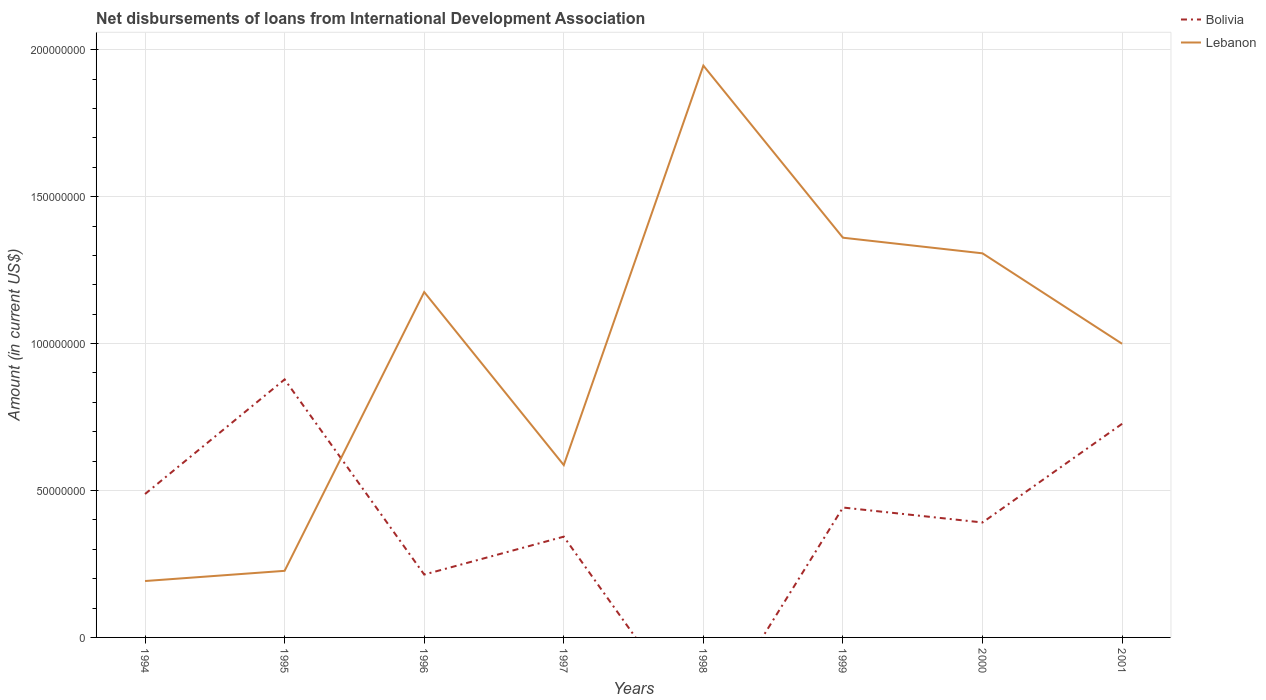How many different coloured lines are there?
Keep it short and to the point. 2. Is the number of lines equal to the number of legend labels?
Give a very brief answer. No. Across all years, what is the maximum amount of loans disbursed in Lebanon?
Offer a very short reply. 1.92e+07. What is the total amount of loans disbursed in Lebanon in the graph?
Make the answer very short. -3.95e+07. What is the difference between the highest and the second highest amount of loans disbursed in Lebanon?
Offer a terse response. 1.75e+08. What is the difference between the highest and the lowest amount of loans disbursed in Bolivia?
Your answer should be compact. 4. How many lines are there?
Your response must be concise. 2. Are the values on the major ticks of Y-axis written in scientific E-notation?
Your response must be concise. No. Does the graph contain grids?
Offer a terse response. Yes. How many legend labels are there?
Offer a terse response. 2. What is the title of the graph?
Your answer should be compact. Net disbursements of loans from International Development Association. What is the label or title of the X-axis?
Provide a succinct answer. Years. What is the Amount (in current US$) in Bolivia in 1994?
Ensure brevity in your answer.  4.88e+07. What is the Amount (in current US$) in Lebanon in 1994?
Ensure brevity in your answer.  1.92e+07. What is the Amount (in current US$) in Bolivia in 1995?
Make the answer very short. 8.78e+07. What is the Amount (in current US$) of Lebanon in 1995?
Ensure brevity in your answer.  2.27e+07. What is the Amount (in current US$) of Bolivia in 1996?
Your response must be concise. 2.14e+07. What is the Amount (in current US$) in Lebanon in 1996?
Offer a terse response. 1.18e+08. What is the Amount (in current US$) in Bolivia in 1997?
Make the answer very short. 3.43e+07. What is the Amount (in current US$) of Lebanon in 1997?
Make the answer very short. 5.87e+07. What is the Amount (in current US$) of Lebanon in 1998?
Your answer should be compact. 1.95e+08. What is the Amount (in current US$) in Bolivia in 1999?
Your response must be concise. 4.42e+07. What is the Amount (in current US$) of Lebanon in 1999?
Offer a terse response. 1.36e+08. What is the Amount (in current US$) in Bolivia in 2000?
Ensure brevity in your answer.  3.91e+07. What is the Amount (in current US$) in Lebanon in 2000?
Provide a short and direct response. 1.31e+08. What is the Amount (in current US$) of Bolivia in 2001?
Your answer should be very brief. 7.27e+07. What is the Amount (in current US$) of Lebanon in 2001?
Provide a short and direct response. 9.99e+07. Across all years, what is the maximum Amount (in current US$) of Bolivia?
Your answer should be compact. 8.78e+07. Across all years, what is the maximum Amount (in current US$) in Lebanon?
Provide a short and direct response. 1.95e+08. Across all years, what is the minimum Amount (in current US$) of Lebanon?
Make the answer very short. 1.92e+07. What is the total Amount (in current US$) in Bolivia in the graph?
Make the answer very short. 3.48e+08. What is the total Amount (in current US$) in Lebanon in the graph?
Give a very brief answer. 7.79e+08. What is the difference between the Amount (in current US$) of Bolivia in 1994 and that in 1995?
Make the answer very short. -3.90e+07. What is the difference between the Amount (in current US$) of Lebanon in 1994 and that in 1995?
Your answer should be compact. -3.47e+06. What is the difference between the Amount (in current US$) in Bolivia in 1994 and that in 1996?
Offer a terse response. 2.74e+07. What is the difference between the Amount (in current US$) in Lebanon in 1994 and that in 1996?
Offer a terse response. -9.84e+07. What is the difference between the Amount (in current US$) in Bolivia in 1994 and that in 1997?
Give a very brief answer. 1.45e+07. What is the difference between the Amount (in current US$) of Lebanon in 1994 and that in 1997?
Your answer should be compact. -3.95e+07. What is the difference between the Amount (in current US$) of Lebanon in 1994 and that in 1998?
Your answer should be compact. -1.75e+08. What is the difference between the Amount (in current US$) in Bolivia in 1994 and that in 1999?
Make the answer very short. 4.60e+06. What is the difference between the Amount (in current US$) in Lebanon in 1994 and that in 1999?
Your response must be concise. -1.17e+08. What is the difference between the Amount (in current US$) of Bolivia in 1994 and that in 2000?
Your response must be concise. 9.69e+06. What is the difference between the Amount (in current US$) of Lebanon in 1994 and that in 2000?
Your response must be concise. -1.12e+08. What is the difference between the Amount (in current US$) of Bolivia in 1994 and that in 2001?
Give a very brief answer. -2.39e+07. What is the difference between the Amount (in current US$) of Lebanon in 1994 and that in 2001?
Your response must be concise. -8.07e+07. What is the difference between the Amount (in current US$) in Bolivia in 1995 and that in 1996?
Your answer should be compact. 6.64e+07. What is the difference between the Amount (in current US$) of Lebanon in 1995 and that in 1996?
Your answer should be compact. -9.49e+07. What is the difference between the Amount (in current US$) of Bolivia in 1995 and that in 1997?
Make the answer very short. 5.35e+07. What is the difference between the Amount (in current US$) of Lebanon in 1995 and that in 1997?
Make the answer very short. -3.60e+07. What is the difference between the Amount (in current US$) in Lebanon in 1995 and that in 1998?
Your answer should be very brief. -1.72e+08. What is the difference between the Amount (in current US$) in Bolivia in 1995 and that in 1999?
Offer a very short reply. 4.36e+07. What is the difference between the Amount (in current US$) in Lebanon in 1995 and that in 1999?
Give a very brief answer. -1.13e+08. What is the difference between the Amount (in current US$) in Bolivia in 1995 and that in 2000?
Make the answer very short. 4.87e+07. What is the difference between the Amount (in current US$) in Lebanon in 1995 and that in 2000?
Your answer should be compact. -1.08e+08. What is the difference between the Amount (in current US$) in Bolivia in 1995 and that in 2001?
Offer a terse response. 1.51e+07. What is the difference between the Amount (in current US$) in Lebanon in 1995 and that in 2001?
Provide a succinct answer. -7.73e+07. What is the difference between the Amount (in current US$) of Bolivia in 1996 and that in 1997?
Your answer should be compact. -1.29e+07. What is the difference between the Amount (in current US$) of Lebanon in 1996 and that in 1997?
Your response must be concise. 5.89e+07. What is the difference between the Amount (in current US$) in Lebanon in 1996 and that in 1998?
Offer a terse response. -7.71e+07. What is the difference between the Amount (in current US$) of Bolivia in 1996 and that in 1999?
Ensure brevity in your answer.  -2.28e+07. What is the difference between the Amount (in current US$) of Lebanon in 1996 and that in 1999?
Ensure brevity in your answer.  -1.85e+07. What is the difference between the Amount (in current US$) in Bolivia in 1996 and that in 2000?
Offer a very short reply. -1.77e+07. What is the difference between the Amount (in current US$) in Lebanon in 1996 and that in 2000?
Your answer should be very brief. -1.32e+07. What is the difference between the Amount (in current US$) of Bolivia in 1996 and that in 2001?
Your answer should be very brief. -5.13e+07. What is the difference between the Amount (in current US$) of Lebanon in 1996 and that in 2001?
Provide a succinct answer. 1.76e+07. What is the difference between the Amount (in current US$) in Lebanon in 1997 and that in 1998?
Give a very brief answer. -1.36e+08. What is the difference between the Amount (in current US$) in Bolivia in 1997 and that in 1999?
Provide a succinct answer. -9.91e+06. What is the difference between the Amount (in current US$) of Lebanon in 1997 and that in 1999?
Your response must be concise. -7.74e+07. What is the difference between the Amount (in current US$) in Bolivia in 1997 and that in 2000?
Offer a very short reply. -4.82e+06. What is the difference between the Amount (in current US$) in Lebanon in 1997 and that in 2000?
Offer a terse response. -7.21e+07. What is the difference between the Amount (in current US$) in Bolivia in 1997 and that in 2001?
Make the answer very short. -3.84e+07. What is the difference between the Amount (in current US$) of Lebanon in 1997 and that in 2001?
Offer a very short reply. -4.13e+07. What is the difference between the Amount (in current US$) of Lebanon in 1998 and that in 1999?
Your answer should be very brief. 5.86e+07. What is the difference between the Amount (in current US$) in Lebanon in 1998 and that in 2000?
Your answer should be compact. 6.39e+07. What is the difference between the Amount (in current US$) of Lebanon in 1998 and that in 2001?
Provide a short and direct response. 9.47e+07. What is the difference between the Amount (in current US$) of Bolivia in 1999 and that in 2000?
Make the answer very short. 5.09e+06. What is the difference between the Amount (in current US$) of Lebanon in 1999 and that in 2000?
Offer a very short reply. 5.32e+06. What is the difference between the Amount (in current US$) in Bolivia in 1999 and that in 2001?
Provide a short and direct response. -2.85e+07. What is the difference between the Amount (in current US$) in Lebanon in 1999 and that in 2001?
Make the answer very short. 3.61e+07. What is the difference between the Amount (in current US$) in Bolivia in 2000 and that in 2001?
Your answer should be very brief. -3.36e+07. What is the difference between the Amount (in current US$) of Lebanon in 2000 and that in 2001?
Your answer should be very brief. 3.08e+07. What is the difference between the Amount (in current US$) in Bolivia in 1994 and the Amount (in current US$) in Lebanon in 1995?
Offer a terse response. 2.61e+07. What is the difference between the Amount (in current US$) of Bolivia in 1994 and the Amount (in current US$) of Lebanon in 1996?
Ensure brevity in your answer.  -6.87e+07. What is the difference between the Amount (in current US$) of Bolivia in 1994 and the Amount (in current US$) of Lebanon in 1997?
Your answer should be very brief. -9.85e+06. What is the difference between the Amount (in current US$) of Bolivia in 1994 and the Amount (in current US$) of Lebanon in 1998?
Offer a very short reply. -1.46e+08. What is the difference between the Amount (in current US$) of Bolivia in 1994 and the Amount (in current US$) of Lebanon in 1999?
Your answer should be compact. -8.72e+07. What is the difference between the Amount (in current US$) of Bolivia in 1994 and the Amount (in current US$) of Lebanon in 2000?
Your response must be concise. -8.19e+07. What is the difference between the Amount (in current US$) in Bolivia in 1994 and the Amount (in current US$) in Lebanon in 2001?
Make the answer very short. -5.11e+07. What is the difference between the Amount (in current US$) of Bolivia in 1995 and the Amount (in current US$) of Lebanon in 1996?
Ensure brevity in your answer.  -2.97e+07. What is the difference between the Amount (in current US$) of Bolivia in 1995 and the Amount (in current US$) of Lebanon in 1997?
Make the answer very short. 2.92e+07. What is the difference between the Amount (in current US$) of Bolivia in 1995 and the Amount (in current US$) of Lebanon in 1998?
Offer a terse response. -1.07e+08. What is the difference between the Amount (in current US$) in Bolivia in 1995 and the Amount (in current US$) in Lebanon in 1999?
Ensure brevity in your answer.  -4.82e+07. What is the difference between the Amount (in current US$) in Bolivia in 1995 and the Amount (in current US$) in Lebanon in 2000?
Ensure brevity in your answer.  -4.29e+07. What is the difference between the Amount (in current US$) of Bolivia in 1995 and the Amount (in current US$) of Lebanon in 2001?
Offer a very short reply. -1.21e+07. What is the difference between the Amount (in current US$) in Bolivia in 1996 and the Amount (in current US$) in Lebanon in 1997?
Make the answer very short. -3.73e+07. What is the difference between the Amount (in current US$) of Bolivia in 1996 and the Amount (in current US$) of Lebanon in 1998?
Provide a succinct answer. -1.73e+08. What is the difference between the Amount (in current US$) of Bolivia in 1996 and the Amount (in current US$) of Lebanon in 1999?
Provide a short and direct response. -1.15e+08. What is the difference between the Amount (in current US$) in Bolivia in 1996 and the Amount (in current US$) in Lebanon in 2000?
Your answer should be very brief. -1.09e+08. What is the difference between the Amount (in current US$) of Bolivia in 1996 and the Amount (in current US$) of Lebanon in 2001?
Ensure brevity in your answer.  -7.85e+07. What is the difference between the Amount (in current US$) of Bolivia in 1997 and the Amount (in current US$) of Lebanon in 1998?
Your answer should be very brief. -1.60e+08. What is the difference between the Amount (in current US$) of Bolivia in 1997 and the Amount (in current US$) of Lebanon in 1999?
Make the answer very short. -1.02e+08. What is the difference between the Amount (in current US$) in Bolivia in 1997 and the Amount (in current US$) in Lebanon in 2000?
Make the answer very short. -9.64e+07. What is the difference between the Amount (in current US$) in Bolivia in 1997 and the Amount (in current US$) in Lebanon in 2001?
Keep it short and to the point. -6.56e+07. What is the difference between the Amount (in current US$) in Bolivia in 1999 and the Amount (in current US$) in Lebanon in 2000?
Provide a short and direct response. -8.65e+07. What is the difference between the Amount (in current US$) in Bolivia in 1999 and the Amount (in current US$) in Lebanon in 2001?
Provide a short and direct response. -5.57e+07. What is the difference between the Amount (in current US$) of Bolivia in 2000 and the Amount (in current US$) of Lebanon in 2001?
Your response must be concise. -6.08e+07. What is the average Amount (in current US$) of Bolivia per year?
Offer a very short reply. 4.35e+07. What is the average Amount (in current US$) in Lebanon per year?
Your response must be concise. 9.74e+07. In the year 1994, what is the difference between the Amount (in current US$) in Bolivia and Amount (in current US$) in Lebanon?
Make the answer very short. 2.96e+07. In the year 1995, what is the difference between the Amount (in current US$) of Bolivia and Amount (in current US$) of Lebanon?
Ensure brevity in your answer.  6.51e+07. In the year 1996, what is the difference between the Amount (in current US$) of Bolivia and Amount (in current US$) of Lebanon?
Your answer should be very brief. -9.61e+07. In the year 1997, what is the difference between the Amount (in current US$) of Bolivia and Amount (in current US$) of Lebanon?
Your answer should be compact. -2.44e+07. In the year 1999, what is the difference between the Amount (in current US$) of Bolivia and Amount (in current US$) of Lebanon?
Provide a succinct answer. -9.18e+07. In the year 2000, what is the difference between the Amount (in current US$) in Bolivia and Amount (in current US$) in Lebanon?
Provide a succinct answer. -9.16e+07. In the year 2001, what is the difference between the Amount (in current US$) in Bolivia and Amount (in current US$) in Lebanon?
Offer a very short reply. -2.72e+07. What is the ratio of the Amount (in current US$) of Bolivia in 1994 to that in 1995?
Make the answer very short. 0.56. What is the ratio of the Amount (in current US$) in Lebanon in 1994 to that in 1995?
Your response must be concise. 0.85. What is the ratio of the Amount (in current US$) in Bolivia in 1994 to that in 1996?
Give a very brief answer. 2.28. What is the ratio of the Amount (in current US$) of Lebanon in 1994 to that in 1996?
Offer a terse response. 0.16. What is the ratio of the Amount (in current US$) in Bolivia in 1994 to that in 1997?
Your answer should be compact. 1.42. What is the ratio of the Amount (in current US$) in Lebanon in 1994 to that in 1997?
Make the answer very short. 0.33. What is the ratio of the Amount (in current US$) in Lebanon in 1994 to that in 1998?
Your answer should be very brief. 0.1. What is the ratio of the Amount (in current US$) in Bolivia in 1994 to that in 1999?
Provide a short and direct response. 1.1. What is the ratio of the Amount (in current US$) of Lebanon in 1994 to that in 1999?
Keep it short and to the point. 0.14. What is the ratio of the Amount (in current US$) of Bolivia in 1994 to that in 2000?
Give a very brief answer. 1.25. What is the ratio of the Amount (in current US$) in Lebanon in 1994 to that in 2000?
Your response must be concise. 0.15. What is the ratio of the Amount (in current US$) of Bolivia in 1994 to that in 2001?
Make the answer very short. 0.67. What is the ratio of the Amount (in current US$) of Lebanon in 1994 to that in 2001?
Make the answer very short. 0.19. What is the ratio of the Amount (in current US$) of Bolivia in 1995 to that in 1996?
Offer a terse response. 4.1. What is the ratio of the Amount (in current US$) of Lebanon in 1995 to that in 1996?
Offer a terse response. 0.19. What is the ratio of the Amount (in current US$) in Bolivia in 1995 to that in 1997?
Offer a very short reply. 2.56. What is the ratio of the Amount (in current US$) of Lebanon in 1995 to that in 1997?
Provide a short and direct response. 0.39. What is the ratio of the Amount (in current US$) in Lebanon in 1995 to that in 1998?
Offer a terse response. 0.12. What is the ratio of the Amount (in current US$) in Bolivia in 1995 to that in 1999?
Give a very brief answer. 1.99. What is the ratio of the Amount (in current US$) in Lebanon in 1995 to that in 1999?
Provide a short and direct response. 0.17. What is the ratio of the Amount (in current US$) of Bolivia in 1995 to that in 2000?
Keep it short and to the point. 2.24. What is the ratio of the Amount (in current US$) in Lebanon in 1995 to that in 2000?
Keep it short and to the point. 0.17. What is the ratio of the Amount (in current US$) of Bolivia in 1995 to that in 2001?
Your answer should be very brief. 1.21. What is the ratio of the Amount (in current US$) in Lebanon in 1995 to that in 2001?
Provide a short and direct response. 0.23. What is the ratio of the Amount (in current US$) in Bolivia in 1996 to that in 1997?
Give a very brief answer. 0.62. What is the ratio of the Amount (in current US$) in Lebanon in 1996 to that in 1997?
Keep it short and to the point. 2. What is the ratio of the Amount (in current US$) in Lebanon in 1996 to that in 1998?
Give a very brief answer. 0.6. What is the ratio of the Amount (in current US$) of Bolivia in 1996 to that in 1999?
Make the answer very short. 0.48. What is the ratio of the Amount (in current US$) of Lebanon in 1996 to that in 1999?
Provide a succinct answer. 0.86. What is the ratio of the Amount (in current US$) in Bolivia in 1996 to that in 2000?
Provide a succinct answer. 0.55. What is the ratio of the Amount (in current US$) in Lebanon in 1996 to that in 2000?
Your answer should be compact. 0.9. What is the ratio of the Amount (in current US$) of Bolivia in 1996 to that in 2001?
Provide a succinct answer. 0.29. What is the ratio of the Amount (in current US$) in Lebanon in 1996 to that in 2001?
Provide a succinct answer. 1.18. What is the ratio of the Amount (in current US$) in Lebanon in 1997 to that in 1998?
Offer a very short reply. 0.3. What is the ratio of the Amount (in current US$) in Bolivia in 1997 to that in 1999?
Give a very brief answer. 0.78. What is the ratio of the Amount (in current US$) in Lebanon in 1997 to that in 1999?
Offer a terse response. 0.43. What is the ratio of the Amount (in current US$) in Bolivia in 1997 to that in 2000?
Give a very brief answer. 0.88. What is the ratio of the Amount (in current US$) in Lebanon in 1997 to that in 2000?
Ensure brevity in your answer.  0.45. What is the ratio of the Amount (in current US$) in Bolivia in 1997 to that in 2001?
Your answer should be compact. 0.47. What is the ratio of the Amount (in current US$) in Lebanon in 1997 to that in 2001?
Give a very brief answer. 0.59. What is the ratio of the Amount (in current US$) of Lebanon in 1998 to that in 1999?
Provide a succinct answer. 1.43. What is the ratio of the Amount (in current US$) in Lebanon in 1998 to that in 2000?
Make the answer very short. 1.49. What is the ratio of the Amount (in current US$) in Lebanon in 1998 to that in 2001?
Offer a terse response. 1.95. What is the ratio of the Amount (in current US$) in Bolivia in 1999 to that in 2000?
Give a very brief answer. 1.13. What is the ratio of the Amount (in current US$) of Lebanon in 1999 to that in 2000?
Keep it short and to the point. 1.04. What is the ratio of the Amount (in current US$) of Bolivia in 1999 to that in 2001?
Your response must be concise. 0.61. What is the ratio of the Amount (in current US$) in Lebanon in 1999 to that in 2001?
Keep it short and to the point. 1.36. What is the ratio of the Amount (in current US$) of Bolivia in 2000 to that in 2001?
Offer a terse response. 0.54. What is the ratio of the Amount (in current US$) of Lebanon in 2000 to that in 2001?
Your response must be concise. 1.31. What is the difference between the highest and the second highest Amount (in current US$) of Bolivia?
Make the answer very short. 1.51e+07. What is the difference between the highest and the second highest Amount (in current US$) of Lebanon?
Give a very brief answer. 5.86e+07. What is the difference between the highest and the lowest Amount (in current US$) of Bolivia?
Ensure brevity in your answer.  8.78e+07. What is the difference between the highest and the lowest Amount (in current US$) of Lebanon?
Keep it short and to the point. 1.75e+08. 